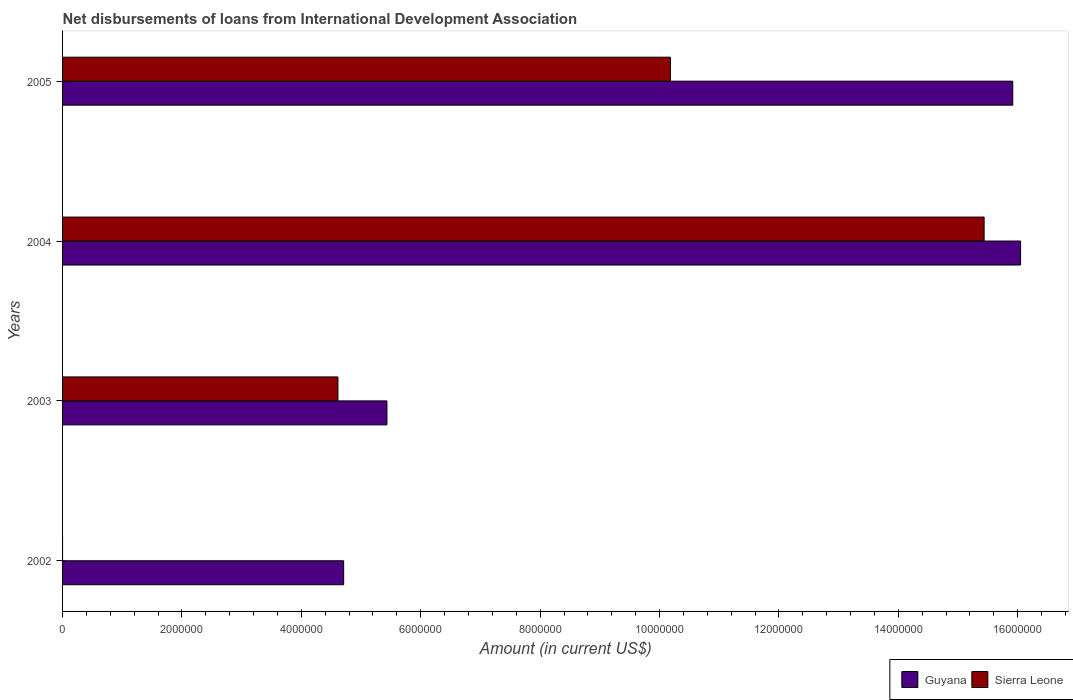Are the number of bars per tick equal to the number of legend labels?
Make the answer very short. No. Are the number of bars on each tick of the Y-axis equal?
Keep it short and to the point. No. What is the amount of loans disbursed in Sierra Leone in 2003?
Your response must be concise. 4.61e+06. Across all years, what is the maximum amount of loans disbursed in Guyana?
Your answer should be compact. 1.60e+07. Across all years, what is the minimum amount of loans disbursed in Sierra Leone?
Your answer should be very brief. 0. In which year was the amount of loans disbursed in Guyana maximum?
Ensure brevity in your answer.  2004. What is the total amount of loans disbursed in Sierra Leone in the graph?
Make the answer very short. 3.02e+07. What is the difference between the amount of loans disbursed in Guyana in 2004 and that in 2005?
Make the answer very short. 1.31e+05. What is the difference between the amount of loans disbursed in Sierra Leone in 2004 and the amount of loans disbursed in Guyana in 2002?
Keep it short and to the point. 1.07e+07. What is the average amount of loans disbursed in Sierra Leone per year?
Provide a succinct answer. 7.56e+06. In the year 2003, what is the difference between the amount of loans disbursed in Guyana and amount of loans disbursed in Sierra Leone?
Offer a very short reply. 8.21e+05. What is the ratio of the amount of loans disbursed in Sierra Leone in 2003 to that in 2005?
Offer a very short reply. 0.45. Is the amount of loans disbursed in Guyana in 2004 less than that in 2005?
Offer a terse response. No. What is the difference between the highest and the second highest amount of loans disbursed in Sierra Leone?
Your response must be concise. 5.26e+06. What is the difference between the highest and the lowest amount of loans disbursed in Guyana?
Ensure brevity in your answer.  1.13e+07. Is the sum of the amount of loans disbursed in Guyana in 2002 and 2005 greater than the maximum amount of loans disbursed in Sierra Leone across all years?
Make the answer very short. Yes. How many bars are there?
Keep it short and to the point. 7. Are all the bars in the graph horizontal?
Give a very brief answer. Yes. What is the difference between two consecutive major ticks on the X-axis?
Provide a short and direct response. 2.00e+06. Are the values on the major ticks of X-axis written in scientific E-notation?
Your answer should be very brief. No. Does the graph contain any zero values?
Your answer should be very brief. Yes. Where does the legend appear in the graph?
Provide a succinct answer. Bottom right. How many legend labels are there?
Your response must be concise. 2. What is the title of the graph?
Keep it short and to the point. Net disbursements of loans from International Development Association. What is the label or title of the X-axis?
Offer a very short reply. Amount (in current US$). What is the Amount (in current US$) of Guyana in 2002?
Make the answer very short. 4.71e+06. What is the Amount (in current US$) in Guyana in 2003?
Your answer should be very brief. 5.43e+06. What is the Amount (in current US$) in Sierra Leone in 2003?
Provide a succinct answer. 4.61e+06. What is the Amount (in current US$) in Guyana in 2004?
Keep it short and to the point. 1.60e+07. What is the Amount (in current US$) of Sierra Leone in 2004?
Offer a terse response. 1.54e+07. What is the Amount (in current US$) in Guyana in 2005?
Make the answer very short. 1.59e+07. What is the Amount (in current US$) of Sierra Leone in 2005?
Make the answer very short. 1.02e+07. Across all years, what is the maximum Amount (in current US$) in Guyana?
Your response must be concise. 1.60e+07. Across all years, what is the maximum Amount (in current US$) of Sierra Leone?
Offer a terse response. 1.54e+07. Across all years, what is the minimum Amount (in current US$) of Guyana?
Your response must be concise. 4.71e+06. What is the total Amount (in current US$) of Guyana in the graph?
Your answer should be compact. 4.21e+07. What is the total Amount (in current US$) of Sierra Leone in the graph?
Offer a very short reply. 3.02e+07. What is the difference between the Amount (in current US$) of Guyana in 2002 and that in 2003?
Offer a terse response. -7.25e+05. What is the difference between the Amount (in current US$) in Guyana in 2002 and that in 2004?
Keep it short and to the point. -1.13e+07. What is the difference between the Amount (in current US$) in Guyana in 2002 and that in 2005?
Offer a terse response. -1.12e+07. What is the difference between the Amount (in current US$) of Guyana in 2003 and that in 2004?
Make the answer very short. -1.06e+07. What is the difference between the Amount (in current US$) in Sierra Leone in 2003 and that in 2004?
Provide a short and direct response. -1.08e+07. What is the difference between the Amount (in current US$) of Guyana in 2003 and that in 2005?
Give a very brief answer. -1.05e+07. What is the difference between the Amount (in current US$) of Sierra Leone in 2003 and that in 2005?
Give a very brief answer. -5.57e+06. What is the difference between the Amount (in current US$) of Guyana in 2004 and that in 2005?
Make the answer very short. 1.31e+05. What is the difference between the Amount (in current US$) in Sierra Leone in 2004 and that in 2005?
Your answer should be very brief. 5.26e+06. What is the difference between the Amount (in current US$) in Guyana in 2002 and the Amount (in current US$) in Sierra Leone in 2003?
Your response must be concise. 9.60e+04. What is the difference between the Amount (in current US$) of Guyana in 2002 and the Amount (in current US$) of Sierra Leone in 2004?
Your response must be concise. -1.07e+07. What is the difference between the Amount (in current US$) of Guyana in 2002 and the Amount (in current US$) of Sierra Leone in 2005?
Your answer should be compact. -5.47e+06. What is the difference between the Amount (in current US$) in Guyana in 2003 and the Amount (in current US$) in Sierra Leone in 2004?
Offer a terse response. -1.00e+07. What is the difference between the Amount (in current US$) in Guyana in 2003 and the Amount (in current US$) in Sierra Leone in 2005?
Offer a very short reply. -4.75e+06. What is the difference between the Amount (in current US$) in Guyana in 2004 and the Amount (in current US$) in Sierra Leone in 2005?
Offer a very short reply. 5.87e+06. What is the average Amount (in current US$) in Guyana per year?
Offer a terse response. 1.05e+07. What is the average Amount (in current US$) in Sierra Leone per year?
Your answer should be very brief. 7.56e+06. In the year 2003, what is the difference between the Amount (in current US$) of Guyana and Amount (in current US$) of Sierra Leone?
Offer a terse response. 8.21e+05. In the year 2004, what is the difference between the Amount (in current US$) in Guyana and Amount (in current US$) in Sierra Leone?
Your answer should be compact. 6.11e+05. In the year 2005, what is the difference between the Amount (in current US$) of Guyana and Amount (in current US$) of Sierra Leone?
Provide a succinct answer. 5.74e+06. What is the ratio of the Amount (in current US$) in Guyana in 2002 to that in 2003?
Keep it short and to the point. 0.87. What is the ratio of the Amount (in current US$) of Guyana in 2002 to that in 2004?
Your answer should be very brief. 0.29. What is the ratio of the Amount (in current US$) of Guyana in 2002 to that in 2005?
Your answer should be compact. 0.3. What is the ratio of the Amount (in current US$) of Guyana in 2003 to that in 2004?
Give a very brief answer. 0.34. What is the ratio of the Amount (in current US$) of Sierra Leone in 2003 to that in 2004?
Your response must be concise. 0.3. What is the ratio of the Amount (in current US$) of Guyana in 2003 to that in 2005?
Make the answer very short. 0.34. What is the ratio of the Amount (in current US$) of Sierra Leone in 2003 to that in 2005?
Give a very brief answer. 0.45. What is the ratio of the Amount (in current US$) in Guyana in 2004 to that in 2005?
Offer a very short reply. 1.01. What is the ratio of the Amount (in current US$) in Sierra Leone in 2004 to that in 2005?
Your answer should be very brief. 1.52. What is the difference between the highest and the second highest Amount (in current US$) of Guyana?
Your answer should be compact. 1.31e+05. What is the difference between the highest and the second highest Amount (in current US$) in Sierra Leone?
Provide a succinct answer. 5.26e+06. What is the difference between the highest and the lowest Amount (in current US$) of Guyana?
Give a very brief answer. 1.13e+07. What is the difference between the highest and the lowest Amount (in current US$) in Sierra Leone?
Offer a very short reply. 1.54e+07. 